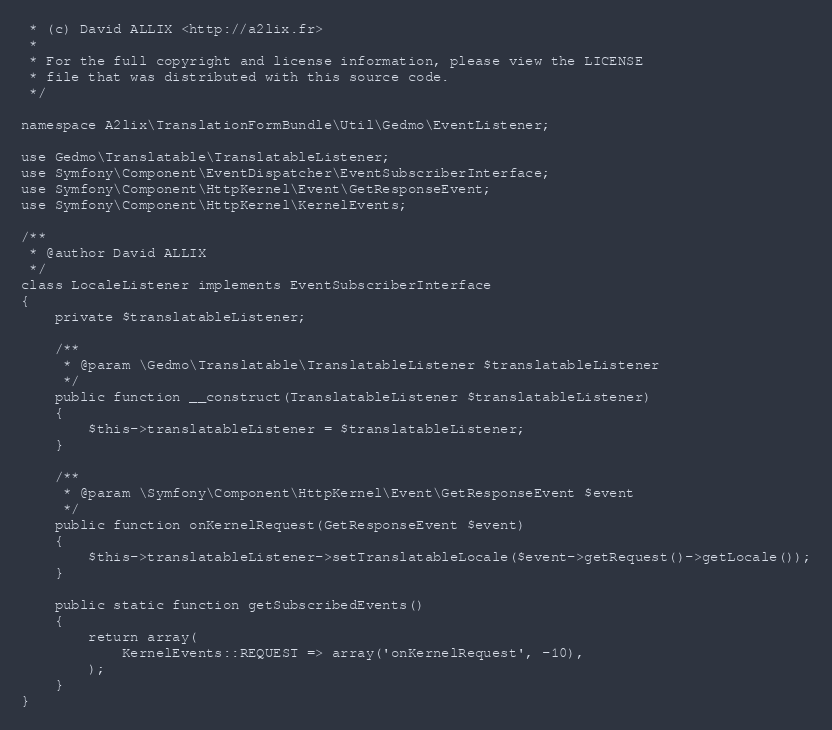Convert code to text. <code><loc_0><loc_0><loc_500><loc_500><_PHP_> * (c) David ALLIX <http://a2lix.fr>
 *
 * For the full copyright and license information, please view the LICENSE
 * file that was distributed with this source code.
 */

namespace A2lix\TranslationFormBundle\Util\Gedmo\EventListener;

use Gedmo\Translatable\TranslatableListener;
use Symfony\Component\EventDispatcher\EventSubscriberInterface;
use Symfony\Component\HttpKernel\Event\GetResponseEvent;
use Symfony\Component\HttpKernel\KernelEvents;

/**
 * @author David ALLIX
 */
class LocaleListener implements EventSubscriberInterface
{
    private $translatableListener;

    /**
     * @param \Gedmo\Translatable\TranslatableListener $translatableListener
     */
    public function __construct(TranslatableListener $translatableListener)
    {
        $this->translatableListener = $translatableListener;
    }

    /**
     * @param \Symfony\Component\HttpKernel\Event\GetResponseEvent $event
     */
    public function onKernelRequest(GetResponseEvent $event)
    {
        $this->translatableListener->setTranslatableLocale($event->getRequest()->getLocale());
    }

    public static function getSubscribedEvents()
    {
        return array(
            KernelEvents::REQUEST => array('onKernelRequest', -10),
        );
    }
}
</code> 